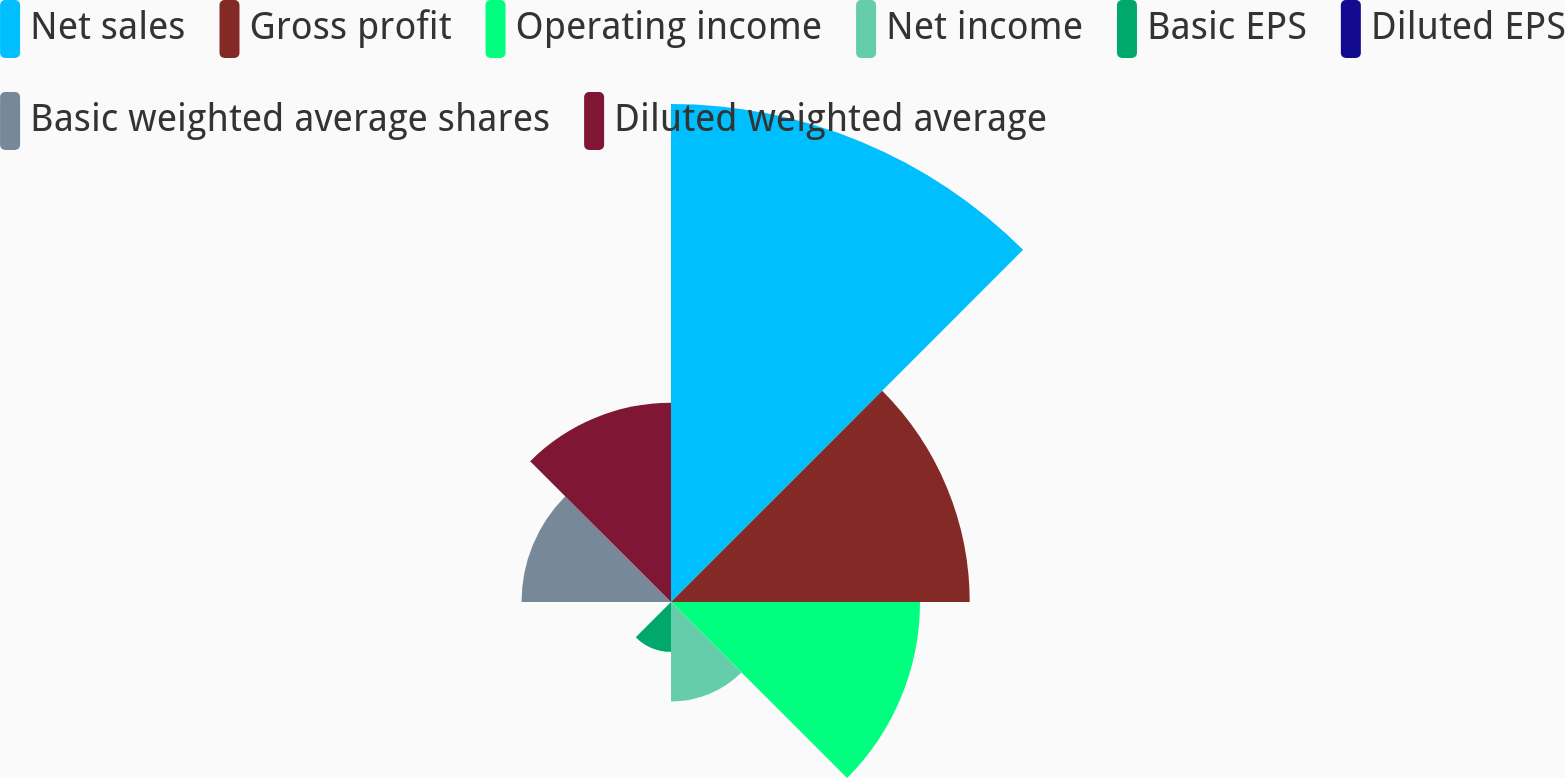Convert chart to OTSL. <chart><loc_0><loc_0><loc_500><loc_500><pie_chart><fcel>Net sales<fcel>Gross profit<fcel>Operating income<fcel>Net income<fcel>Basic EPS<fcel>Diluted EPS<fcel>Basic weighted average shares<fcel>Diluted weighted average<nl><fcel>32.26%<fcel>19.35%<fcel>16.13%<fcel>6.45%<fcel>3.23%<fcel>0.0%<fcel>9.68%<fcel>12.9%<nl></chart> 